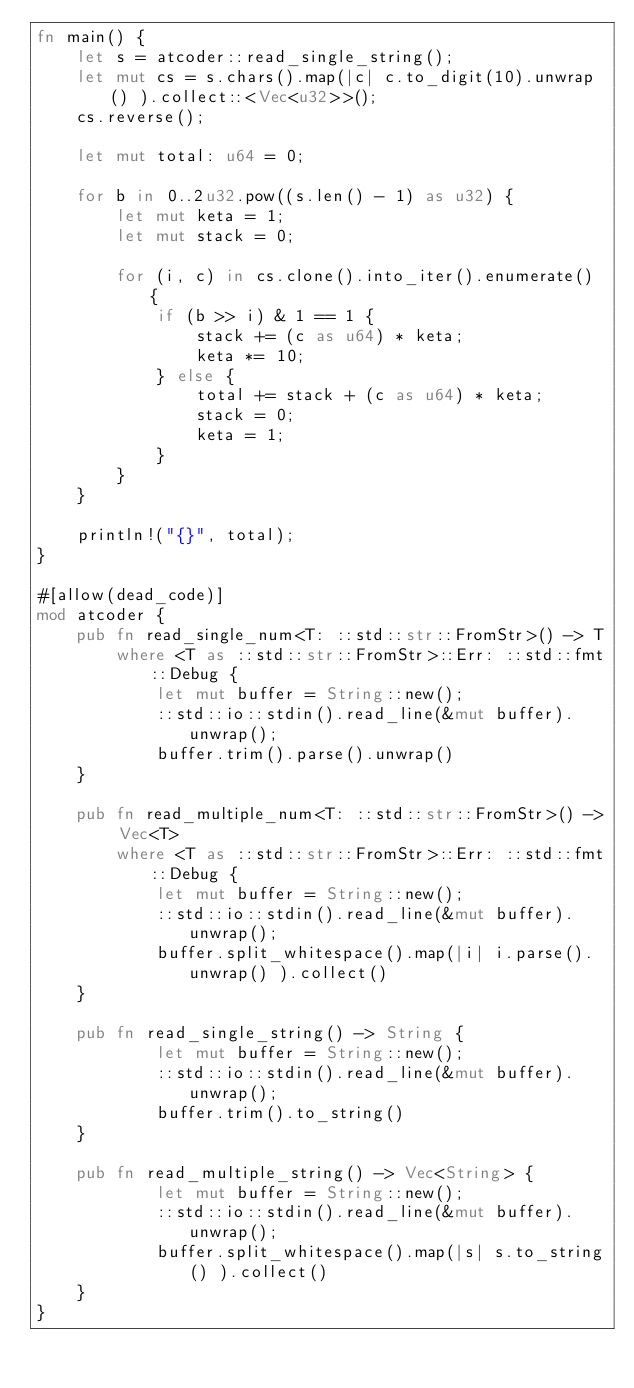<code> <loc_0><loc_0><loc_500><loc_500><_Rust_>fn main() {
    let s = atcoder::read_single_string();
    let mut cs = s.chars().map(|c| c.to_digit(10).unwrap() ).collect::<Vec<u32>>();
    cs.reverse();

    let mut total: u64 = 0;

    for b in 0..2u32.pow((s.len() - 1) as u32) {
        let mut keta = 1;
        let mut stack = 0;

        for (i, c) in cs.clone().into_iter().enumerate() {
            if (b >> i) & 1 == 1 {
                stack += (c as u64) * keta;
                keta *= 10;
            } else {
                total += stack + (c as u64) * keta;
                stack = 0;
                keta = 1;
            }
        }
    }

    println!("{}", total);
}

#[allow(dead_code)]
mod atcoder {
    pub fn read_single_num<T: ::std::str::FromStr>() -> T
        where <T as ::std::str::FromStr>::Err: ::std::fmt::Debug {
            let mut buffer = String::new();
            ::std::io::stdin().read_line(&mut buffer).unwrap();
            buffer.trim().parse().unwrap()
    }

    pub fn read_multiple_num<T: ::std::str::FromStr>() -> Vec<T>
        where <T as ::std::str::FromStr>::Err: ::std::fmt::Debug {
            let mut buffer = String::new();
            ::std::io::stdin().read_line(&mut buffer).unwrap();
            buffer.split_whitespace().map(|i| i.parse().unwrap() ).collect()
    }

    pub fn read_single_string() -> String {
            let mut buffer = String::new();
            ::std::io::stdin().read_line(&mut buffer).unwrap();
            buffer.trim().to_string()
    }

    pub fn read_multiple_string() -> Vec<String> {
            let mut buffer = String::new();
            ::std::io::stdin().read_line(&mut buffer).unwrap();
            buffer.split_whitespace().map(|s| s.to_string() ).collect()
    }
}
</code> 